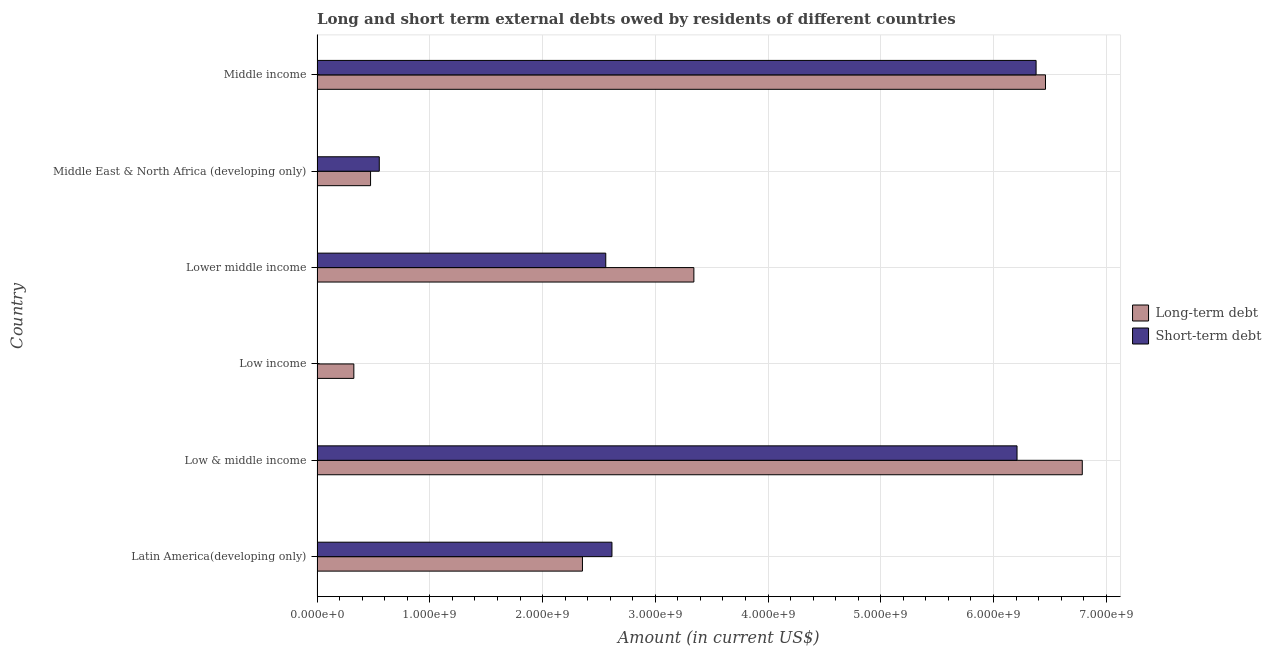How many different coloured bars are there?
Offer a very short reply. 2. Are the number of bars on each tick of the Y-axis equal?
Your answer should be compact. No. How many bars are there on the 2nd tick from the top?
Make the answer very short. 2. How many bars are there on the 5th tick from the bottom?
Your response must be concise. 2. What is the label of the 3rd group of bars from the top?
Provide a short and direct response. Lower middle income. What is the short-term debts owed by residents in Middle income?
Provide a succinct answer. 6.38e+09. Across all countries, what is the maximum short-term debts owed by residents?
Your response must be concise. 6.38e+09. Across all countries, what is the minimum short-term debts owed by residents?
Your answer should be compact. 0. In which country was the short-term debts owed by residents maximum?
Make the answer very short. Middle income. What is the total short-term debts owed by residents in the graph?
Make the answer very short. 1.83e+1. What is the difference between the short-term debts owed by residents in Latin America(developing only) and that in Middle East & North Africa (developing only)?
Your answer should be very brief. 2.06e+09. What is the difference between the short-term debts owed by residents in Latin America(developing only) and the long-term debts owed by residents in Low income?
Provide a succinct answer. 2.29e+09. What is the average short-term debts owed by residents per country?
Keep it short and to the point. 3.05e+09. What is the difference between the short-term debts owed by residents and long-term debts owed by residents in Low & middle income?
Your answer should be compact. -5.79e+08. What is the ratio of the short-term debts owed by residents in Low & middle income to that in Middle East & North Africa (developing only)?
Provide a short and direct response. 11.25. What is the difference between the highest and the second highest short-term debts owed by residents?
Give a very brief answer. 1.69e+08. What is the difference between the highest and the lowest long-term debts owed by residents?
Keep it short and to the point. 6.46e+09. Does the graph contain any zero values?
Provide a short and direct response. Yes. Does the graph contain grids?
Your answer should be compact. Yes. What is the title of the graph?
Ensure brevity in your answer.  Long and short term external debts owed by residents of different countries. What is the label or title of the X-axis?
Your answer should be very brief. Amount (in current US$). What is the label or title of the Y-axis?
Provide a short and direct response. Country. What is the Amount (in current US$) of Long-term debt in Latin America(developing only)?
Offer a terse response. 2.35e+09. What is the Amount (in current US$) of Short-term debt in Latin America(developing only)?
Ensure brevity in your answer.  2.62e+09. What is the Amount (in current US$) of Long-term debt in Low & middle income?
Your response must be concise. 6.79e+09. What is the Amount (in current US$) of Short-term debt in Low & middle income?
Offer a terse response. 6.21e+09. What is the Amount (in current US$) in Long-term debt in Low income?
Provide a short and direct response. 3.26e+08. What is the Amount (in current US$) in Short-term debt in Low income?
Your answer should be very brief. 0. What is the Amount (in current US$) in Long-term debt in Lower middle income?
Your response must be concise. 3.34e+09. What is the Amount (in current US$) in Short-term debt in Lower middle income?
Keep it short and to the point. 2.56e+09. What is the Amount (in current US$) in Long-term debt in Middle East & North Africa (developing only)?
Keep it short and to the point. 4.75e+08. What is the Amount (in current US$) in Short-term debt in Middle East & North Africa (developing only)?
Your response must be concise. 5.52e+08. What is the Amount (in current US$) of Long-term debt in Middle income?
Ensure brevity in your answer.  6.46e+09. What is the Amount (in current US$) of Short-term debt in Middle income?
Your response must be concise. 6.38e+09. Across all countries, what is the maximum Amount (in current US$) of Long-term debt?
Ensure brevity in your answer.  6.79e+09. Across all countries, what is the maximum Amount (in current US$) of Short-term debt?
Your response must be concise. 6.38e+09. Across all countries, what is the minimum Amount (in current US$) in Long-term debt?
Ensure brevity in your answer.  3.26e+08. Across all countries, what is the minimum Amount (in current US$) of Short-term debt?
Offer a very short reply. 0. What is the total Amount (in current US$) of Long-term debt in the graph?
Offer a terse response. 1.97e+1. What is the total Amount (in current US$) in Short-term debt in the graph?
Provide a succinct answer. 1.83e+1. What is the difference between the Amount (in current US$) of Long-term debt in Latin America(developing only) and that in Low & middle income?
Your answer should be very brief. -4.43e+09. What is the difference between the Amount (in current US$) in Short-term debt in Latin America(developing only) and that in Low & middle income?
Make the answer very short. -3.59e+09. What is the difference between the Amount (in current US$) in Long-term debt in Latin America(developing only) and that in Low income?
Provide a short and direct response. 2.03e+09. What is the difference between the Amount (in current US$) in Long-term debt in Latin America(developing only) and that in Lower middle income?
Make the answer very short. -9.88e+08. What is the difference between the Amount (in current US$) in Short-term debt in Latin America(developing only) and that in Lower middle income?
Make the answer very short. 5.48e+07. What is the difference between the Amount (in current US$) in Long-term debt in Latin America(developing only) and that in Middle East & North Africa (developing only)?
Offer a terse response. 1.88e+09. What is the difference between the Amount (in current US$) of Short-term debt in Latin America(developing only) and that in Middle East & North Africa (developing only)?
Make the answer very short. 2.06e+09. What is the difference between the Amount (in current US$) in Long-term debt in Latin America(developing only) and that in Middle income?
Ensure brevity in your answer.  -4.11e+09. What is the difference between the Amount (in current US$) in Short-term debt in Latin America(developing only) and that in Middle income?
Give a very brief answer. -3.76e+09. What is the difference between the Amount (in current US$) of Long-term debt in Low & middle income and that in Low income?
Offer a very short reply. 6.46e+09. What is the difference between the Amount (in current US$) in Long-term debt in Low & middle income and that in Lower middle income?
Your response must be concise. 3.44e+09. What is the difference between the Amount (in current US$) in Short-term debt in Low & middle income and that in Lower middle income?
Your response must be concise. 3.65e+09. What is the difference between the Amount (in current US$) in Long-term debt in Low & middle income and that in Middle East & North Africa (developing only)?
Offer a terse response. 6.31e+09. What is the difference between the Amount (in current US$) of Short-term debt in Low & middle income and that in Middle East & North Africa (developing only)?
Make the answer very short. 5.66e+09. What is the difference between the Amount (in current US$) in Long-term debt in Low & middle income and that in Middle income?
Offer a very short reply. 3.26e+08. What is the difference between the Amount (in current US$) of Short-term debt in Low & middle income and that in Middle income?
Your answer should be compact. -1.69e+08. What is the difference between the Amount (in current US$) in Long-term debt in Low income and that in Lower middle income?
Your answer should be compact. -3.02e+09. What is the difference between the Amount (in current US$) of Long-term debt in Low income and that in Middle East & North Africa (developing only)?
Keep it short and to the point. -1.48e+08. What is the difference between the Amount (in current US$) in Long-term debt in Low income and that in Middle income?
Give a very brief answer. -6.13e+09. What is the difference between the Amount (in current US$) of Long-term debt in Lower middle income and that in Middle East & North Africa (developing only)?
Ensure brevity in your answer.  2.87e+09. What is the difference between the Amount (in current US$) in Short-term debt in Lower middle income and that in Middle East & North Africa (developing only)?
Give a very brief answer. 2.01e+09. What is the difference between the Amount (in current US$) in Long-term debt in Lower middle income and that in Middle income?
Make the answer very short. -3.12e+09. What is the difference between the Amount (in current US$) of Short-term debt in Lower middle income and that in Middle income?
Your answer should be very brief. -3.82e+09. What is the difference between the Amount (in current US$) in Long-term debt in Middle East & North Africa (developing only) and that in Middle income?
Provide a succinct answer. -5.99e+09. What is the difference between the Amount (in current US$) of Short-term debt in Middle East & North Africa (developing only) and that in Middle income?
Ensure brevity in your answer.  -5.83e+09. What is the difference between the Amount (in current US$) in Long-term debt in Latin America(developing only) and the Amount (in current US$) in Short-term debt in Low & middle income?
Your answer should be very brief. -3.85e+09. What is the difference between the Amount (in current US$) of Long-term debt in Latin America(developing only) and the Amount (in current US$) of Short-term debt in Lower middle income?
Make the answer very short. -2.07e+08. What is the difference between the Amount (in current US$) of Long-term debt in Latin America(developing only) and the Amount (in current US$) of Short-term debt in Middle East & North Africa (developing only)?
Give a very brief answer. 1.80e+09. What is the difference between the Amount (in current US$) of Long-term debt in Latin America(developing only) and the Amount (in current US$) of Short-term debt in Middle income?
Offer a very short reply. -4.02e+09. What is the difference between the Amount (in current US$) of Long-term debt in Low & middle income and the Amount (in current US$) of Short-term debt in Lower middle income?
Your response must be concise. 4.23e+09. What is the difference between the Amount (in current US$) in Long-term debt in Low & middle income and the Amount (in current US$) in Short-term debt in Middle East & North Africa (developing only)?
Make the answer very short. 6.24e+09. What is the difference between the Amount (in current US$) of Long-term debt in Low & middle income and the Amount (in current US$) of Short-term debt in Middle income?
Offer a very short reply. 4.10e+08. What is the difference between the Amount (in current US$) in Long-term debt in Low income and the Amount (in current US$) in Short-term debt in Lower middle income?
Your answer should be very brief. -2.23e+09. What is the difference between the Amount (in current US$) in Long-term debt in Low income and the Amount (in current US$) in Short-term debt in Middle East & North Africa (developing only)?
Your answer should be compact. -2.26e+08. What is the difference between the Amount (in current US$) of Long-term debt in Low income and the Amount (in current US$) of Short-term debt in Middle income?
Your answer should be very brief. -6.05e+09. What is the difference between the Amount (in current US$) in Long-term debt in Lower middle income and the Amount (in current US$) in Short-term debt in Middle East & North Africa (developing only)?
Offer a very short reply. 2.79e+09. What is the difference between the Amount (in current US$) in Long-term debt in Lower middle income and the Amount (in current US$) in Short-term debt in Middle income?
Keep it short and to the point. -3.04e+09. What is the difference between the Amount (in current US$) in Long-term debt in Middle East & North Africa (developing only) and the Amount (in current US$) in Short-term debt in Middle income?
Keep it short and to the point. -5.90e+09. What is the average Amount (in current US$) of Long-term debt per country?
Keep it short and to the point. 3.29e+09. What is the average Amount (in current US$) of Short-term debt per country?
Offer a very short reply. 3.05e+09. What is the difference between the Amount (in current US$) of Long-term debt and Amount (in current US$) of Short-term debt in Latin America(developing only)?
Give a very brief answer. -2.62e+08. What is the difference between the Amount (in current US$) in Long-term debt and Amount (in current US$) in Short-term debt in Low & middle income?
Make the answer very short. 5.79e+08. What is the difference between the Amount (in current US$) in Long-term debt and Amount (in current US$) in Short-term debt in Lower middle income?
Your response must be concise. 7.81e+08. What is the difference between the Amount (in current US$) of Long-term debt and Amount (in current US$) of Short-term debt in Middle East & North Africa (developing only)?
Provide a succinct answer. -7.74e+07. What is the difference between the Amount (in current US$) in Long-term debt and Amount (in current US$) in Short-term debt in Middle income?
Provide a short and direct response. 8.34e+07. What is the ratio of the Amount (in current US$) of Long-term debt in Latin America(developing only) to that in Low & middle income?
Keep it short and to the point. 0.35. What is the ratio of the Amount (in current US$) in Short-term debt in Latin America(developing only) to that in Low & middle income?
Give a very brief answer. 0.42. What is the ratio of the Amount (in current US$) in Long-term debt in Latin America(developing only) to that in Low income?
Ensure brevity in your answer.  7.21. What is the ratio of the Amount (in current US$) of Long-term debt in Latin America(developing only) to that in Lower middle income?
Keep it short and to the point. 0.7. What is the ratio of the Amount (in current US$) in Short-term debt in Latin America(developing only) to that in Lower middle income?
Offer a terse response. 1.02. What is the ratio of the Amount (in current US$) in Long-term debt in Latin America(developing only) to that in Middle East & North Africa (developing only)?
Keep it short and to the point. 4.96. What is the ratio of the Amount (in current US$) of Short-term debt in Latin America(developing only) to that in Middle East & North Africa (developing only)?
Offer a terse response. 4.74. What is the ratio of the Amount (in current US$) in Long-term debt in Latin America(developing only) to that in Middle income?
Give a very brief answer. 0.36. What is the ratio of the Amount (in current US$) in Short-term debt in Latin America(developing only) to that in Middle income?
Provide a short and direct response. 0.41. What is the ratio of the Amount (in current US$) of Long-term debt in Low & middle income to that in Low income?
Your answer should be compact. 20.8. What is the ratio of the Amount (in current US$) of Long-term debt in Low & middle income to that in Lower middle income?
Provide a short and direct response. 2.03. What is the ratio of the Amount (in current US$) of Short-term debt in Low & middle income to that in Lower middle income?
Your answer should be compact. 2.42. What is the ratio of the Amount (in current US$) in Long-term debt in Low & middle income to that in Middle East & North Africa (developing only)?
Your response must be concise. 14.3. What is the ratio of the Amount (in current US$) in Short-term debt in Low & middle income to that in Middle East & North Africa (developing only)?
Offer a very short reply. 11.25. What is the ratio of the Amount (in current US$) of Long-term debt in Low & middle income to that in Middle income?
Your answer should be very brief. 1.05. What is the ratio of the Amount (in current US$) of Short-term debt in Low & middle income to that in Middle income?
Your response must be concise. 0.97. What is the ratio of the Amount (in current US$) in Long-term debt in Low income to that in Lower middle income?
Offer a terse response. 0.1. What is the ratio of the Amount (in current US$) of Long-term debt in Low income to that in Middle East & North Africa (developing only)?
Ensure brevity in your answer.  0.69. What is the ratio of the Amount (in current US$) in Long-term debt in Low income to that in Middle income?
Offer a very short reply. 0.05. What is the ratio of the Amount (in current US$) in Long-term debt in Lower middle income to that in Middle East & North Africa (developing only)?
Your answer should be compact. 7.04. What is the ratio of the Amount (in current US$) of Short-term debt in Lower middle income to that in Middle East & North Africa (developing only)?
Ensure brevity in your answer.  4.64. What is the ratio of the Amount (in current US$) in Long-term debt in Lower middle income to that in Middle income?
Keep it short and to the point. 0.52. What is the ratio of the Amount (in current US$) of Short-term debt in Lower middle income to that in Middle income?
Ensure brevity in your answer.  0.4. What is the ratio of the Amount (in current US$) in Long-term debt in Middle East & North Africa (developing only) to that in Middle income?
Your response must be concise. 0.07. What is the ratio of the Amount (in current US$) in Short-term debt in Middle East & North Africa (developing only) to that in Middle income?
Ensure brevity in your answer.  0.09. What is the difference between the highest and the second highest Amount (in current US$) of Long-term debt?
Ensure brevity in your answer.  3.26e+08. What is the difference between the highest and the second highest Amount (in current US$) of Short-term debt?
Give a very brief answer. 1.69e+08. What is the difference between the highest and the lowest Amount (in current US$) in Long-term debt?
Offer a very short reply. 6.46e+09. What is the difference between the highest and the lowest Amount (in current US$) of Short-term debt?
Provide a short and direct response. 6.38e+09. 